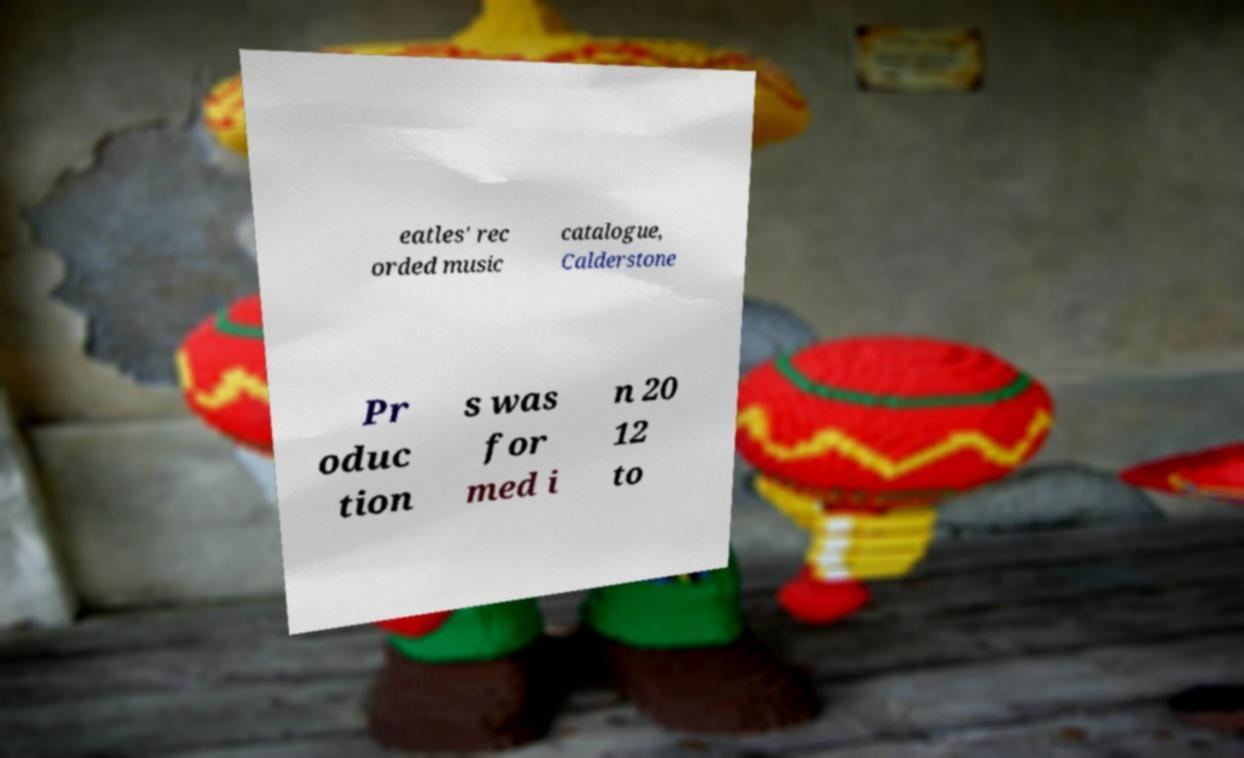For documentation purposes, I need the text within this image transcribed. Could you provide that? eatles' rec orded music catalogue, Calderstone Pr oduc tion s was for med i n 20 12 to 